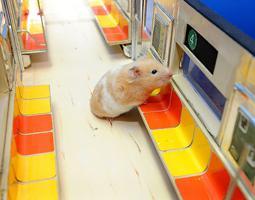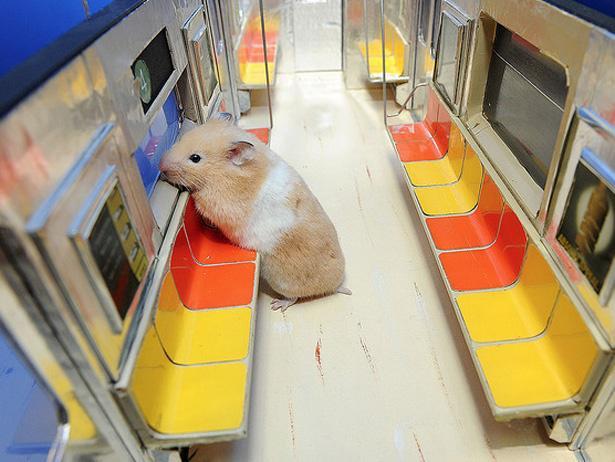The first image is the image on the left, the second image is the image on the right. Assess this claim about the two images: "1 hamster is in the doorway of a toy train car.". Correct or not? Answer yes or no. No. 